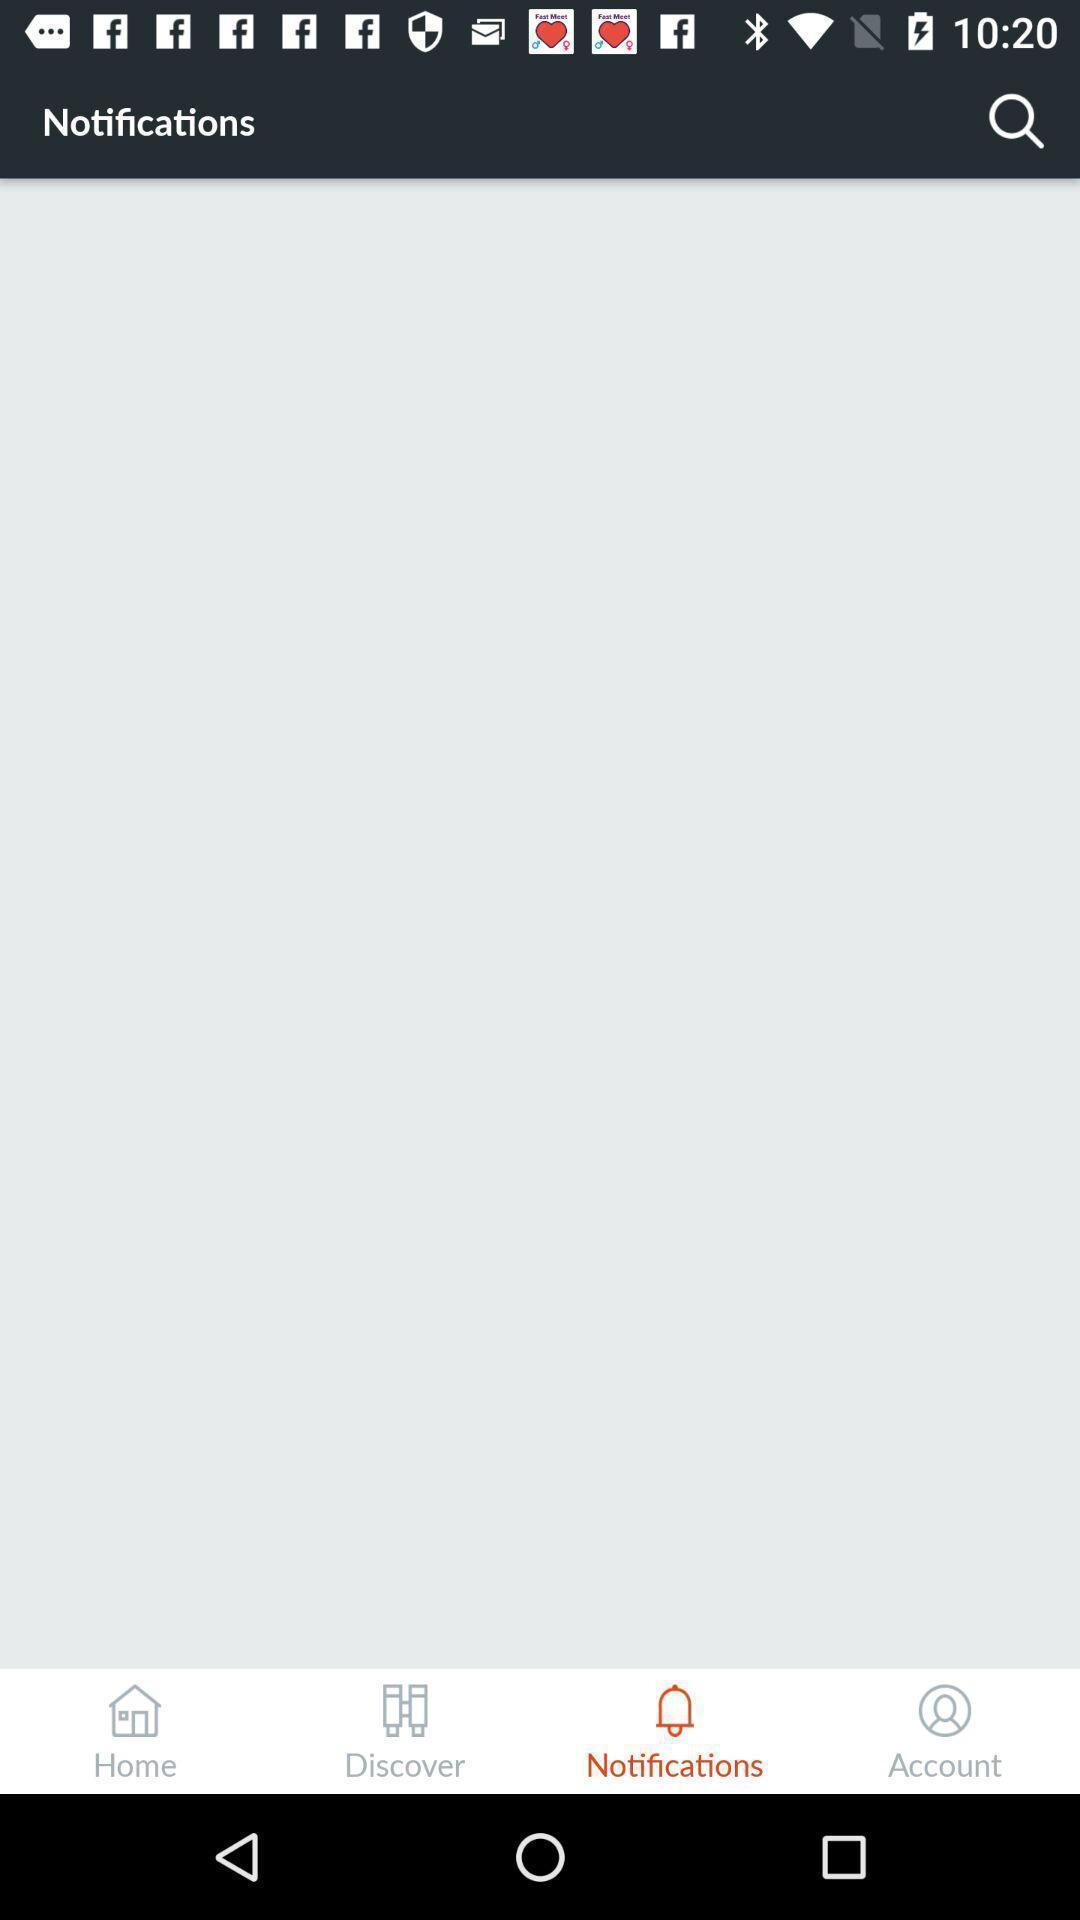Provide a detailed account of this screenshot. Window displaying a notification page. 